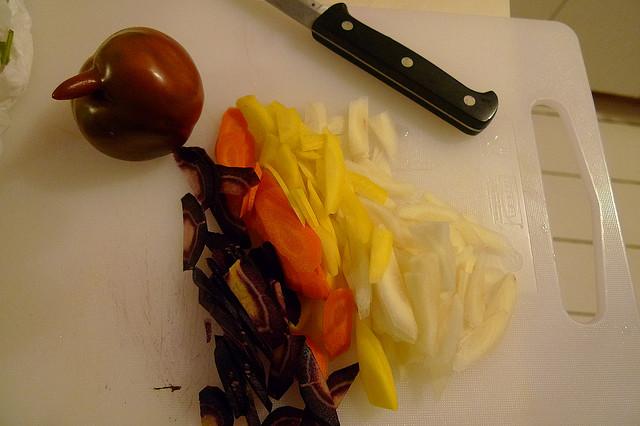What veggies are being cut?
Write a very short answer. Carrots. What is the board called with the vegetables on top?
Short answer required. Cutting board. What is yellow?
Be succinct. Squash. Which fruit is the knife slicing into?
Give a very brief answer. Apple. Has the carrot been cut?
Concise answer only. Yes. 